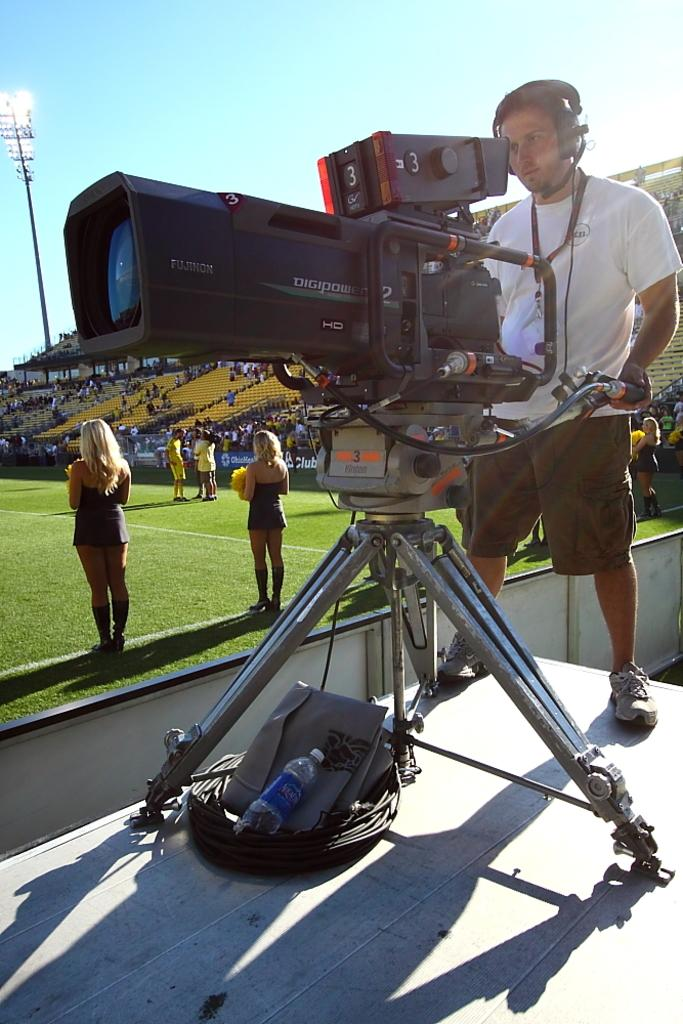<image>
Offer a succinct explanation of the picture presented. A cameraman operating a Digipower camera number 3. 